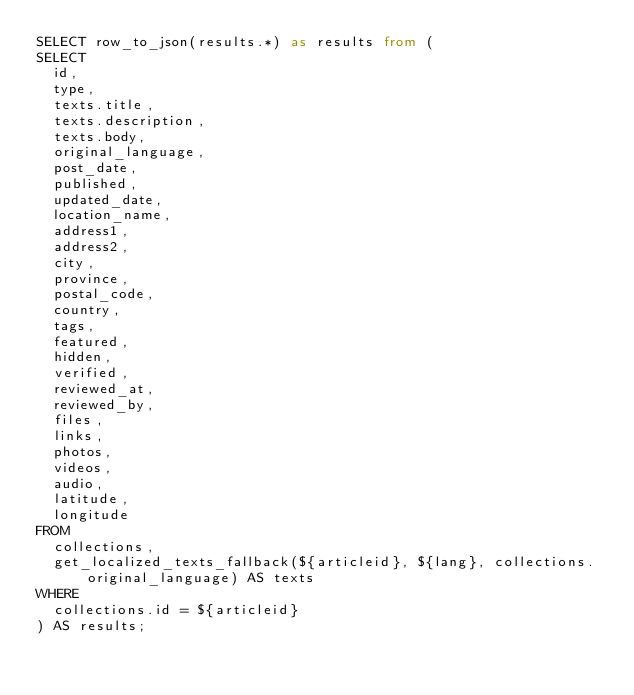<code> <loc_0><loc_0><loc_500><loc_500><_SQL_>SELECT row_to_json(results.*) as results from (
SELECT
  id,
  type,
  texts.title,
  texts.description,
  texts.body,
  original_language,
  post_date,
  published,
  updated_date,
  location_name,
  address1,
  address2,
  city,
  province,
  postal_code,
  country,
  tags,
  featured,
  hidden,
  verified,
  reviewed_at,
  reviewed_by,
  files,
  links,
  photos,
  videos,
  audio,
  latitude,
  longitude
FROM
  collections,
  get_localized_texts_fallback(${articleid}, ${lang}, collections.original_language) AS texts
WHERE
  collections.id = ${articleid}
) AS results;


</code> 